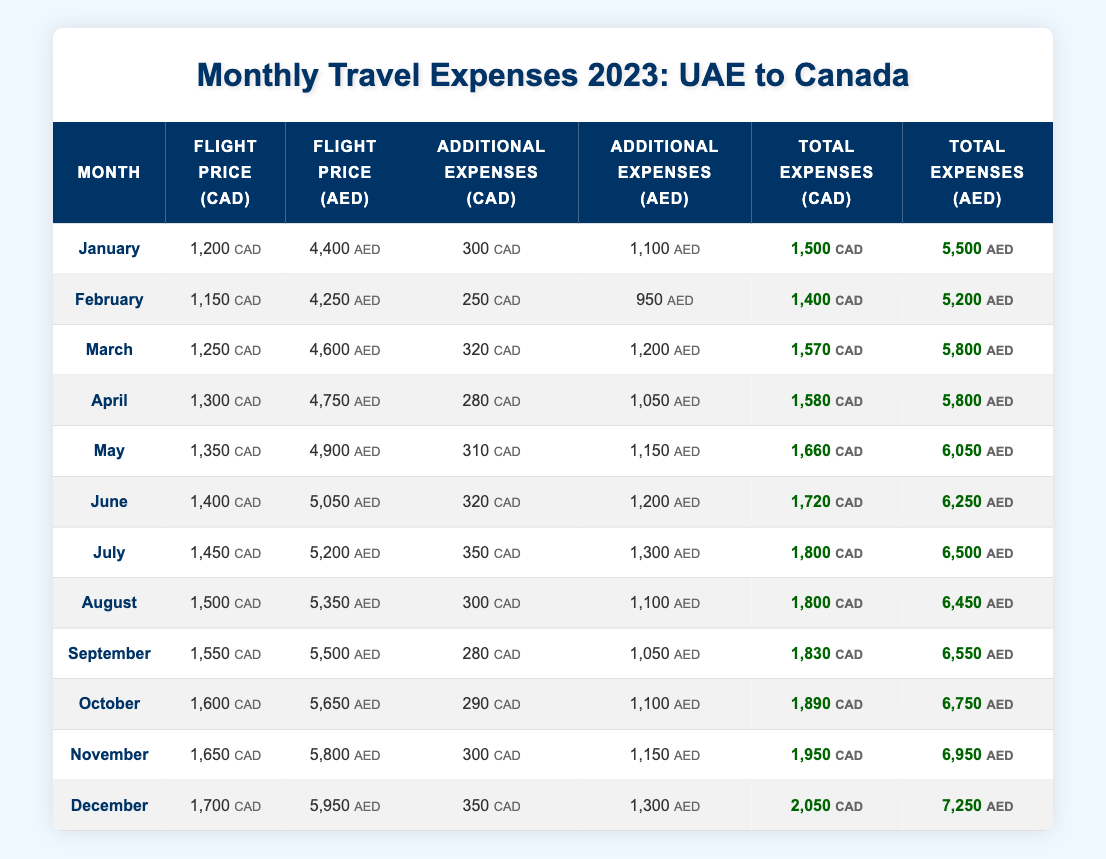What is the flight price in CAD for July? The table lists the flight price in CAD for July as 1450. This value is directly found in the corresponding row for July.
Answer: 1450 What was the total expense in AED for March? The table lists the total expenses in AED for March as 5800. This value is directly found in the corresponding row for March.
Answer: 5800 Which month had the highest total expenses in CAD? By examining the total expenses column for CAD, December has the highest value at 2050, compared to other months.
Answer: December Calculate the average additional expenses in CAD for the first half of the year (January to June). The additional expenses for January to June are 300, 250, 320, 280, 310, and 320. Adding these gives 1880. There are 6 months, so the average is 1880/6 = 313.33.
Answer: 313.33 Is the flight price in CAD for any month greater than 1600? Looking at the flight prices in CAD, the highest value is 1700 in December. This confirms that there is a month where the flight price exceeds 1600.
Answer: Yes What is the difference between the total expenses in CAD for September and November? The total expenses in CAD for September is 1830 and for November is 1950. The difference is 1950 - 1830 = 120.
Answer: 120 Which month had the lowest additional expenses in AED? By scanning the additional expenses in AED, February shows the lowest value at 950. This is the smallest figure in that column.
Answer: February How much were the total expenses in CAD for August? August's total expenses in CAD are explicitly listed in the table as 1800. Simply refer to the respective row for this value.
Answer: 1800 What were the flight prices in AED for the first three months combined? The flight prices for January, February, and March are 4400, 4250, and 4600 AED respectively. Adding these gives a total of 4400 + 4250 + 4600 = 13250 AED.
Answer: 13250 